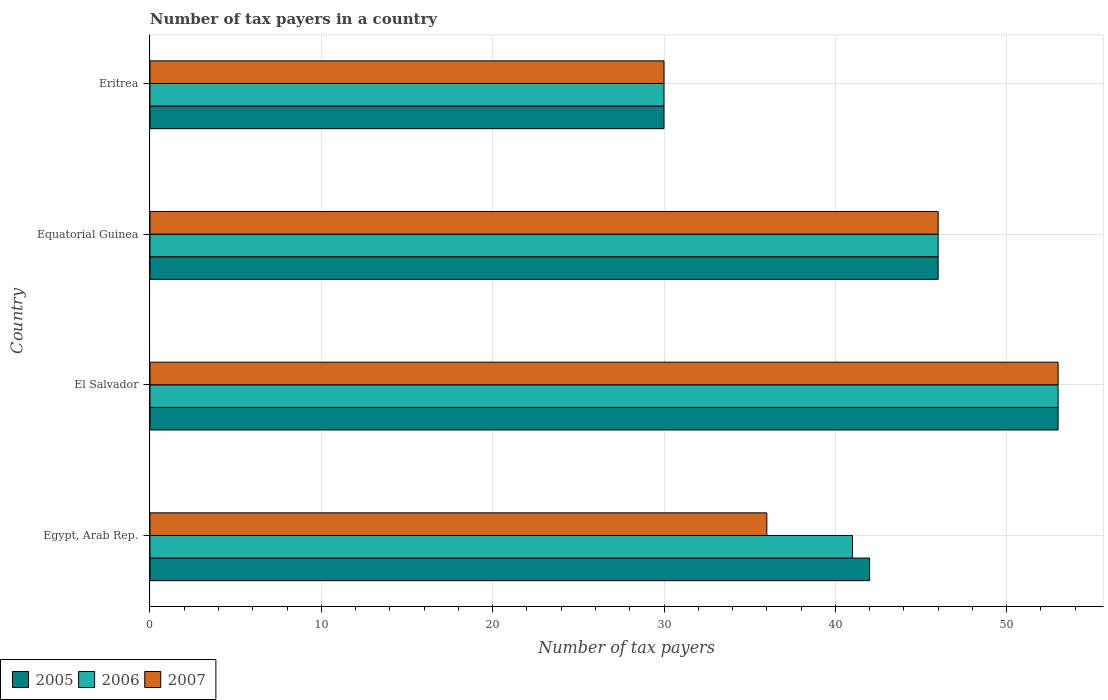How many groups of bars are there?
Your response must be concise. 4. Are the number of bars per tick equal to the number of legend labels?
Provide a short and direct response. Yes. How many bars are there on the 1st tick from the bottom?
Your answer should be compact. 3. What is the label of the 2nd group of bars from the top?
Offer a terse response. Equatorial Guinea. What is the number of tax payers in in 2006 in Egypt, Arab Rep.?
Your response must be concise. 41. Across all countries, what is the maximum number of tax payers in in 2006?
Offer a terse response. 53. Across all countries, what is the minimum number of tax payers in in 2006?
Keep it short and to the point. 30. In which country was the number of tax payers in in 2007 maximum?
Make the answer very short. El Salvador. In which country was the number of tax payers in in 2005 minimum?
Your response must be concise. Eritrea. What is the total number of tax payers in in 2005 in the graph?
Keep it short and to the point. 171. What is the difference between the number of tax payers in in 2005 in Equatorial Guinea and that in Eritrea?
Keep it short and to the point. 16. What is the difference between the number of tax payers in in 2007 in El Salvador and the number of tax payers in in 2005 in Eritrea?
Your answer should be very brief. 23. What is the average number of tax payers in in 2005 per country?
Make the answer very short. 42.75. What is the difference between the number of tax payers in in 2005 and number of tax payers in in 2007 in El Salvador?
Your answer should be very brief. 0. What is the ratio of the number of tax payers in in 2007 in El Salvador to that in Eritrea?
Your answer should be very brief. 1.77. Is the number of tax payers in in 2007 in Egypt, Arab Rep. less than that in El Salvador?
Keep it short and to the point. Yes. What is the difference between the highest and the second highest number of tax payers in in 2006?
Offer a very short reply. 7. What is the difference between the highest and the lowest number of tax payers in in 2007?
Your answer should be compact. 23. What does the 1st bar from the top in El Salvador represents?
Keep it short and to the point. 2007. What does the 3rd bar from the bottom in Equatorial Guinea represents?
Ensure brevity in your answer.  2007. How many bars are there?
Give a very brief answer. 12. Are all the bars in the graph horizontal?
Your answer should be compact. Yes. How many countries are there in the graph?
Offer a terse response. 4. What is the difference between two consecutive major ticks on the X-axis?
Your response must be concise. 10. Does the graph contain grids?
Keep it short and to the point. Yes. What is the title of the graph?
Provide a short and direct response. Number of tax payers in a country. What is the label or title of the X-axis?
Provide a succinct answer. Number of tax payers. What is the Number of tax payers in 2007 in Egypt, Arab Rep.?
Your answer should be very brief. 36. What is the Number of tax payers of 2006 in El Salvador?
Keep it short and to the point. 53. What is the Number of tax payers in 2007 in El Salvador?
Your answer should be compact. 53. What is the Number of tax payers of 2006 in Equatorial Guinea?
Offer a terse response. 46. What is the Number of tax payers in 2007 in Equatorial Guinea?
Offer a very short reply. 46. What is the Number of tax payers of 2006 in Eritrea?
Offer a terse response. 30. Across all countries, what is the maximum Number of tax payers in 2006?
Keep it short and to the point. 53. Across all countries, what is the maximum Number of tax payers in 2007?
Your response must be concise. 53. Across all countries, what is the minimum Number of tax payers in 2005?
Your response must be concise. 30. Across all countries, what is the minimum Number of tax payers of 2006?
Keep it short and to the point. 30. Across all countries, what is the minimum Number of tax payers of 2007?
Keep it short and to the point. 30. What is the total Number of tax payers of 2005 in the graph?
Your response must be concise. 171. What is the total Number of tax payers of 2006 in the graph?
Ensure brevity in your answer.  170. What is the total Number of tax payers in 2007 in the graph?
Ensure brevity in your answer.  165. What is the difference between the Number of tax payers of 2007 in Egypt, Arab Rep. and that in El Salvador?
Provide a succinct answer. -17. What is the difference between the Number of tax payers of 2005 in Egypt, Arab Rep. and that in Equatorial Guinea?
Your response must be concise. -4. What is the difference between the Number of tax payers in 2007 in El Salvador and that in Eritrea?
Keep it short and to the point. 23. What is the difference between the Number of tax payers of 2007 in Equatorial Guinea and that in Eritrea?
Make the answer very short. 16. What is the difference between the Number of tax payers of 2005 in Egypt, Arab Rep. and the Number of tax payers of 2007 in El Salvador?
Make the answer very short. -11. What is the difference between the Number of tax payers of 2006 in Egypt, Arab Rep. and the Number of tax payers of 2007 in El Salvador?
Make the answer very short. -12. What is the difference between the Number of tax payers in 2005 in Egypt, Arab Rep. and the Number of tax payers in 2006 in Equatorial Guinea?
Your answer should be very brief. -4. What is the difference between the Number of tax payers of 2006 in Egypt, Arab Rep. and the Number of tax payers of 2007 in Equatorial Guinea?
Your answer should be very brief. -5. What is the difference between the Number of tax payers of 2006 in Egypt, Arab Rep. and the Number of tax payers of 2007 in Eritrea?
Make the answer very short. 11. What is the difference between the Number of tax payers in 2005 in El Salvador and the Number of tax payers in 2007 in Equatorial Guinea?
Keep it short and to the point. 7. What is the difference between the Number of tax payers of 2005 in El Salvador and the Number of tax payers of 2006 in Eritrea?
Offer a terse response. 23. What is the difference between the Number of tax payers of 2005 in El Salvador and the Number of tax payers of 2007 in Eritrea?
Give a very brief answer. 23. What is the average Number of tax payers in 2005 per country?
Ensure brevity in your answer.  42.75. What is the average Number of tax payers of 2006 per country?
Provide a succinct answer. 42.5. What is the average Number of tax payers of 2007 per country?
Offer a very short reply. 41.25. What is the difference between the Number of tax payers in 2006 and Number of tax payers in 2007 in Egypt, Arab Rep.?
Offer a terse response. 5. What is the difference between the Number of tax payers of 2005 and Number of tax payers of 2007 in El Salvador?
Offer a terse response. 0. What is the difference between the Number of tax payers in 2005 and Number of tax payers in 2006 in Equatorial Guinea?
Your response must be concise. 0. What is the difference between the Number of tax payers of 2005 and Number of tax payers of 2007 in Equatorial Guinea?
Ensure brevity in your answer.  0. What is the difference between the Number of tax payers of 2006 and Number of tax payers of 2007 in Equatorial Guinea?
Provide a succinct answer. 0. What is the difference between the Number of tax payers of 2005 and Number of tax payers of 2006 in Eritrea?
Keep it short and to the point. 0. What is the ratio of the Number of tax payers in 2005 in Egypt, Arab Rep. to that in El Salvador?
Give a very brief answer. 0.79. What is the ratio of the Number of tax payers in 2006 in Egypt, Arab Rep. to that in El Salvador?
Make the answer very short. 0.77. What is the ratio of the Number of tax payers in 2007 in Egypt, Arab Rep. to that in El Salvador?
Offer a very short reply. 0.68. What is the ratio of the Number of tax payers in 2005 in Egypt, Arab Rep. to that in Equatorial Guinea?
Offer a terse response. 0.91. What is the ratio of the Number of tax payers in 2006 in Egypt, Arab Rep. to that in Equatorial Guinea?
Ensure brevity in your answer.  0.89. What is the ratio of the Number of tax payers in 2007 in Egypt, Arab Rep. to that in Equatorial Guinea?
Ensure brevity in your answer.  0.78. What is the ratio of the Number of tax payers of 2006 in Egypt, Arab Rep. to that in Eritrea?
Your answer should be compact. 1.37. What is the ratio of the Number of tax payers in 2005 in El Salvador to that in Equatorial Guinea?
Provide a succinct answer. 1.15. What is the ratio of the Number of tax payers in 2006 in El Salvador to that in Equatorial Guinea?
Your answer should be compact. 1.15. What is the ratio of the Number of tax payers of 2007 in El Salvador to that in Equatorial Guinea?
Give a very brief answer. 1.15. What is the ratio of the Number of tax payers of 2005 in El Salvador to that in Eritrea?
Give a very brief answer. 1.77. What is the ratio of the Number of tax payers in 2006 in El Salvador to that in Eritrea?
Provide a succinct answer. 1.77. What is the ratio of the Number of tax payers of 2007 in El Salvador to that in Eritrea?
Offer a terse response. 1.77. What is the ratio of the Number of tax payers of 2005 in Equatorial Guinea to that in Eritrea?
Make the answer very short. 1.53. What is the ratio of the Number of tax payers in 2006 in Equatorial Guinea to that in Eritrea?
Keep it short and to the point. 1.53. What is the ratio of the Number of tax payers in 2007 in Equatorial Guinea to that in Eritrea?
Provide a short and direct response. 1.53. What is the difference between the highest and the second highest Number of tax payers in 2005?
Offer a terse response. 7. What is the difference between the highest and the second highest Number of tax payers in 2007?
Your answer should be very brief. 7. What is the difference between the highest and the lowest Number of tax payers in 2005?
Make the answer very short. 23. What is the difference between the highest and the lowest Number of tax payers in 2006?
Your answer should be very brief. 23. 